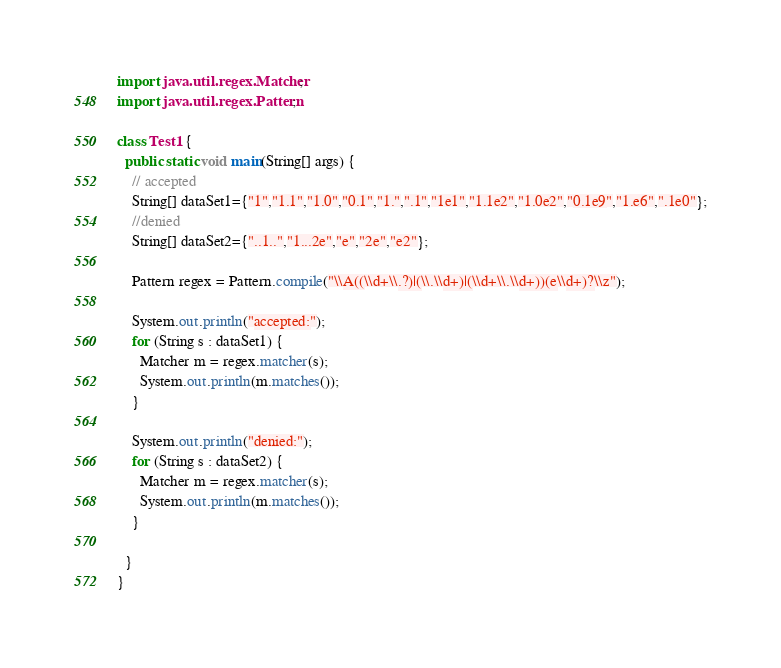<code> <loc_0><loc_0><loc_500><loc_500><_Java_>import java.util.regex.Matcher;
import java.util.regex.Pattern;

class Test1 {
  public static void main(String[] args) {
    // accepted
    String[] dataSet1={"1","1.1","1.0","0.1","1.",".1","1e1","1.1e2","1.0e2","0.1e9","1.e6",".1e0"};
    //denied
    String[] dataSet2={"..1..","1...2e","e","2e","e2"};
    
    Pattern regex = Pattern.compile("\\A((\\d+\\.?)|(\\.\\d+)|(\\d+\\.\\d+))(e\\d+)?\\z");

    System.out.println("accepted:");
    for (String s : dataSet1) {
      Matcher m = regex.matcher(s);
      System.out.println(m.matches());
    }
    
    System.out.println("denied:");
    for (String s : dataSet2) {
      Matcher m = regex.matcher(s);
      System.out.println(m.matches());
    }
      
  }
}
</code> 